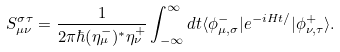<formula> <loc_0><loc_0><loc_500><loc_500>S ^ { \sigma \tau } _ { \mu \nu } = \frac { 1 } { 2 \pi \hbar { ( } \eta ^ { - } _ { \mu } ) ^ { * } \eta ^ { + } _ { \nu } } \int ^ { \infty } _ { - \infty } d t \langle \phi ^ { - } _ { \mu , \sigma } | e ^ { - i H t / } | \phi ^ { + } _ { \nu , \tau } \rangle .</formula> 